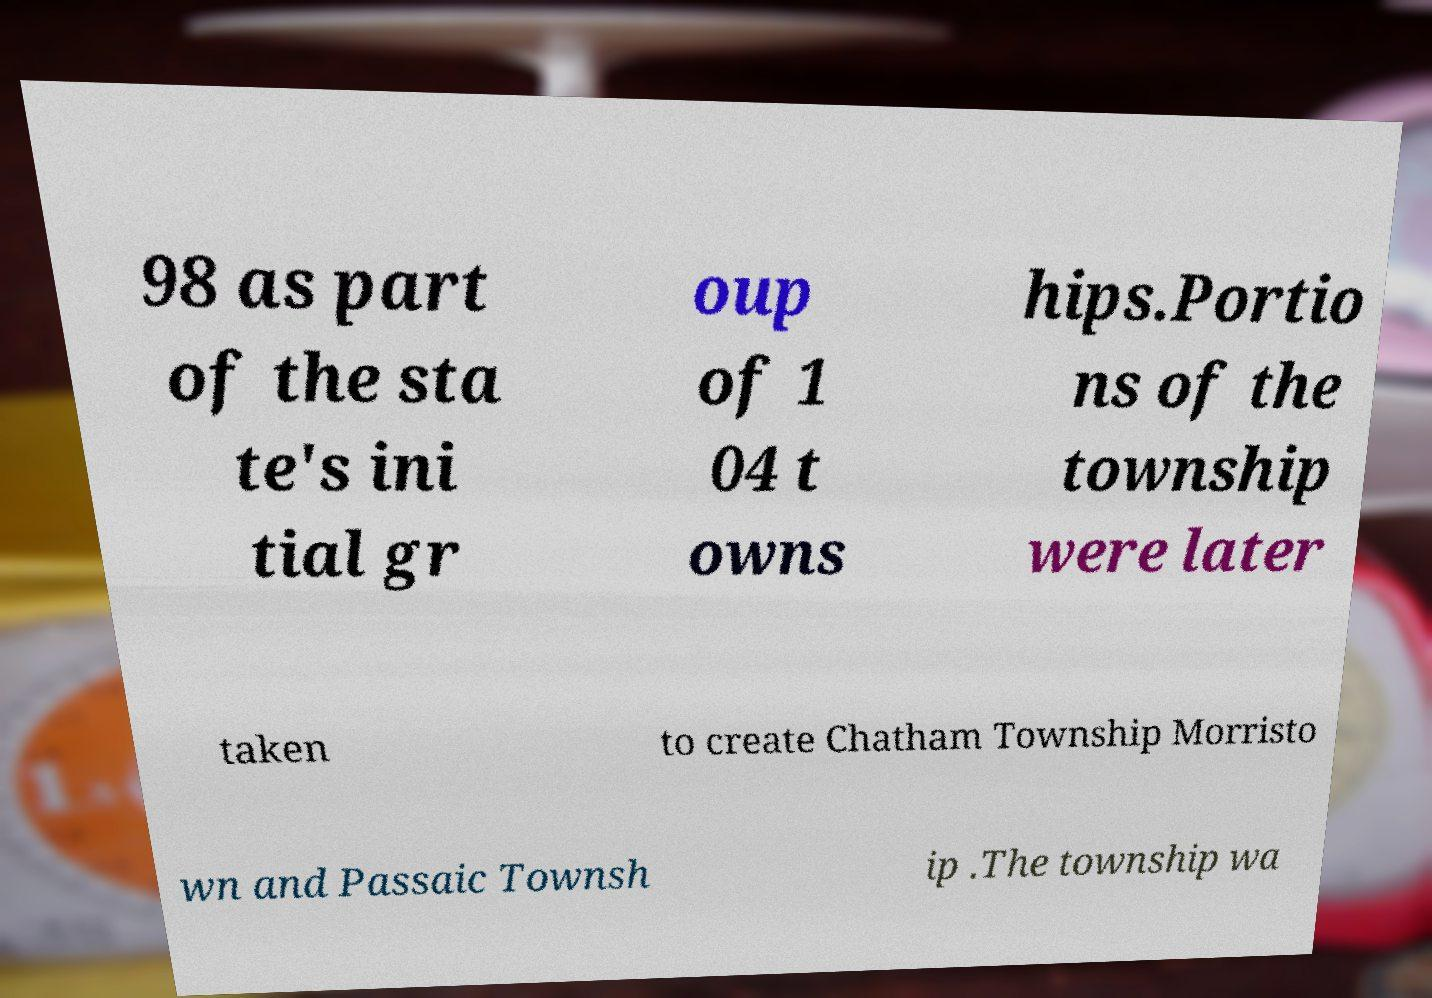Could you assist in decoding the text presented in this image and type it out clearly? 98 as part of the sta te's ini tial gr oup of 1 04 t owns hips.Portio ns of the township were later taken to create Chatham Township Morristo wn and Passaic Townsh ip .The township wa 